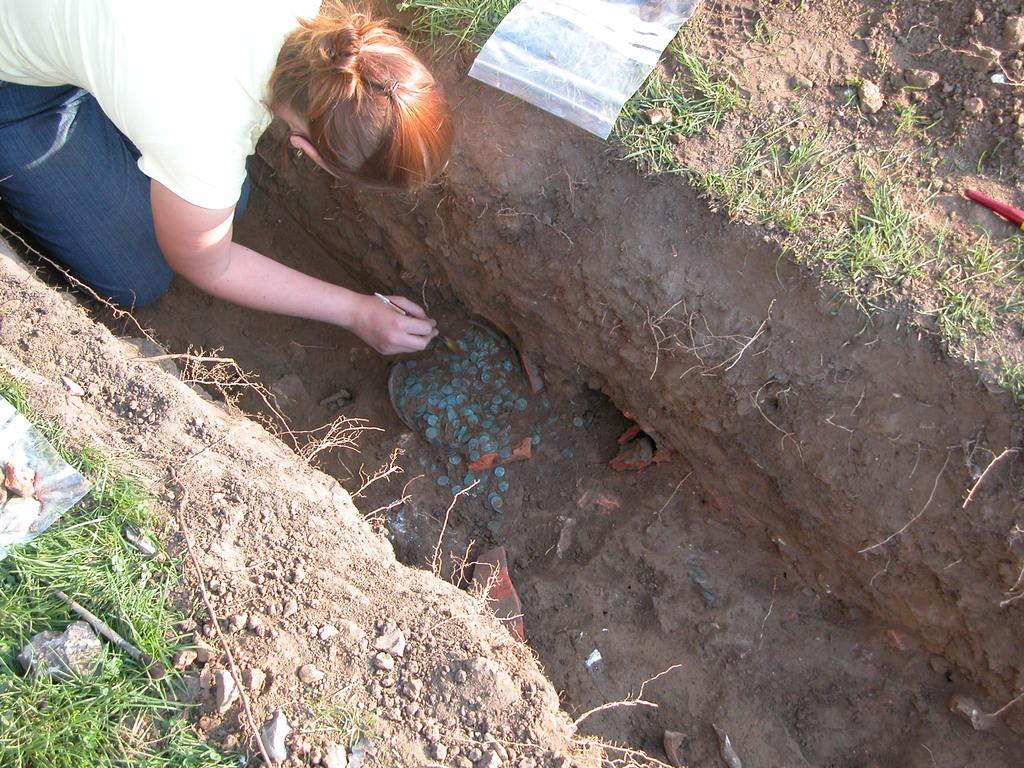Who is the main subject in the image? There is a lady in the image. What is the lady doing in the image? The lady is checking with stones on a pit. What is the purpose of the cover on the ground in the image? The cover on the ground is likely to protect the pit or to keep the stones in place. What type of house can be seen in the background of the image? There is no house visible in the image. 